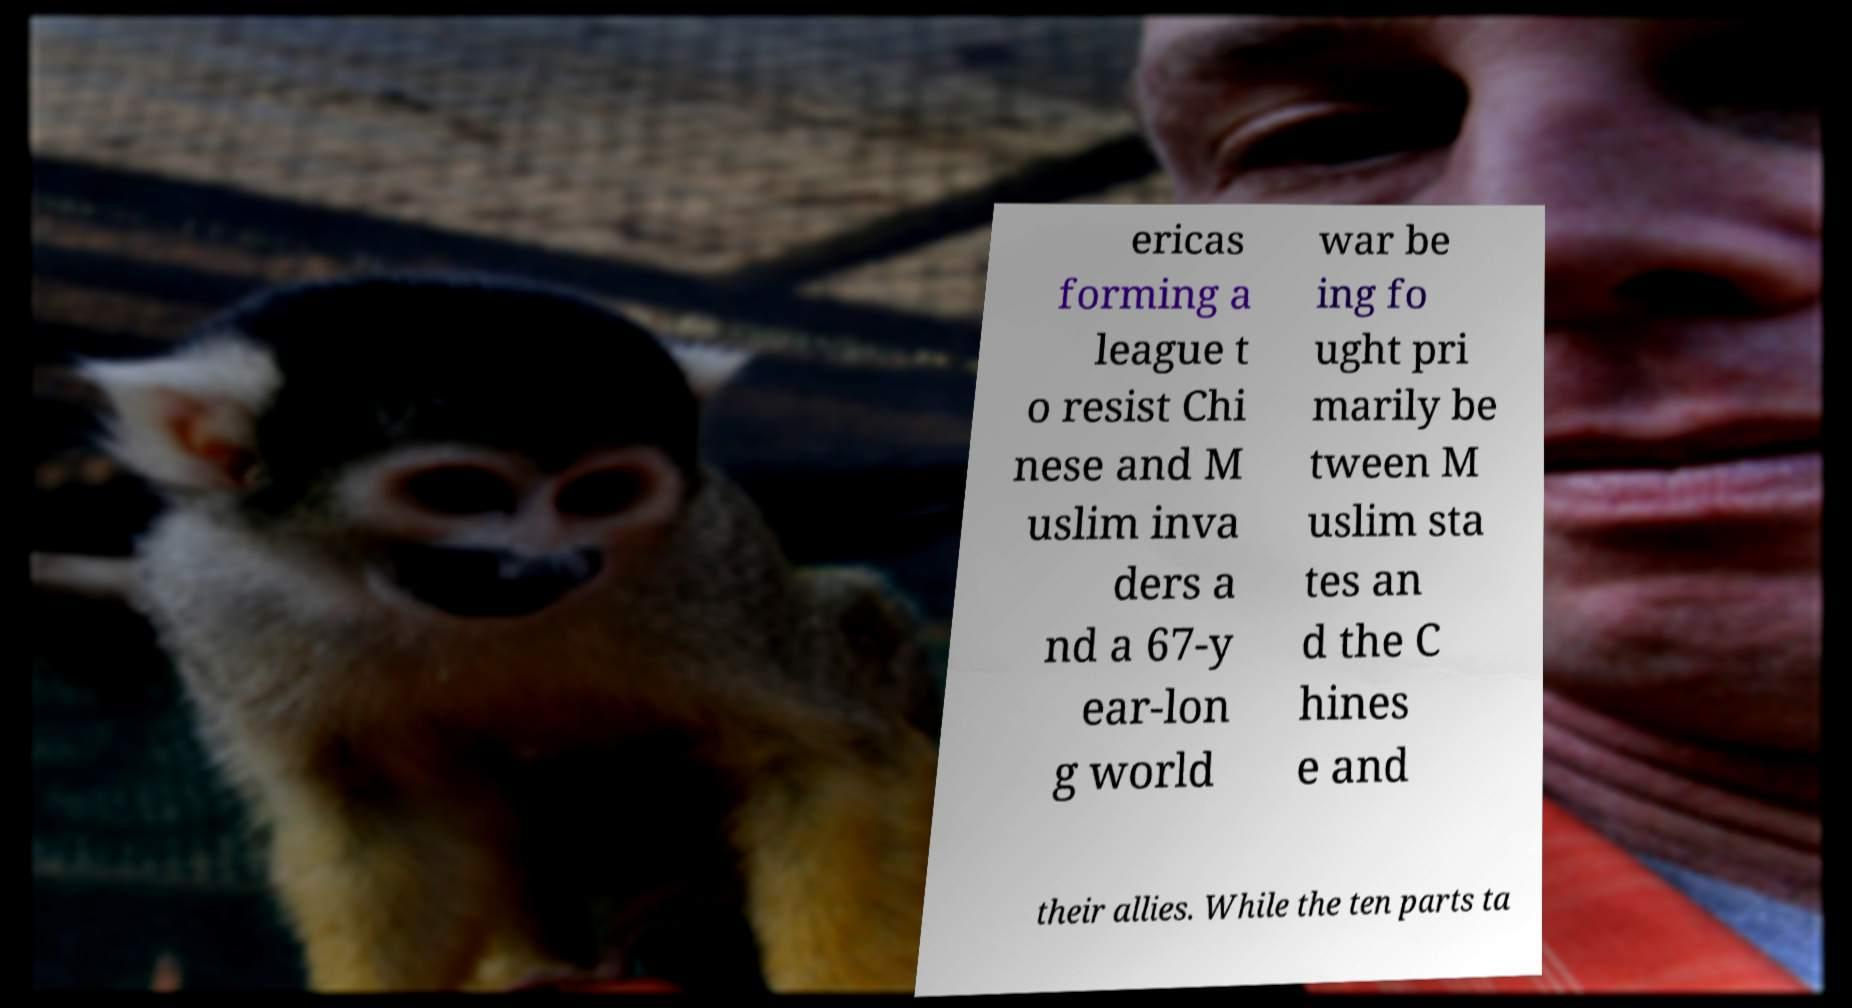Could you extract and type out the text from this image? ericas forming a league t o resist Chi nese and M uslim inva ders a nd a 67-y ear-lon g world war be ing fo ught pri marily be tween M uslim sta tes an d the C hines e and their allies. While the ten parts ta 